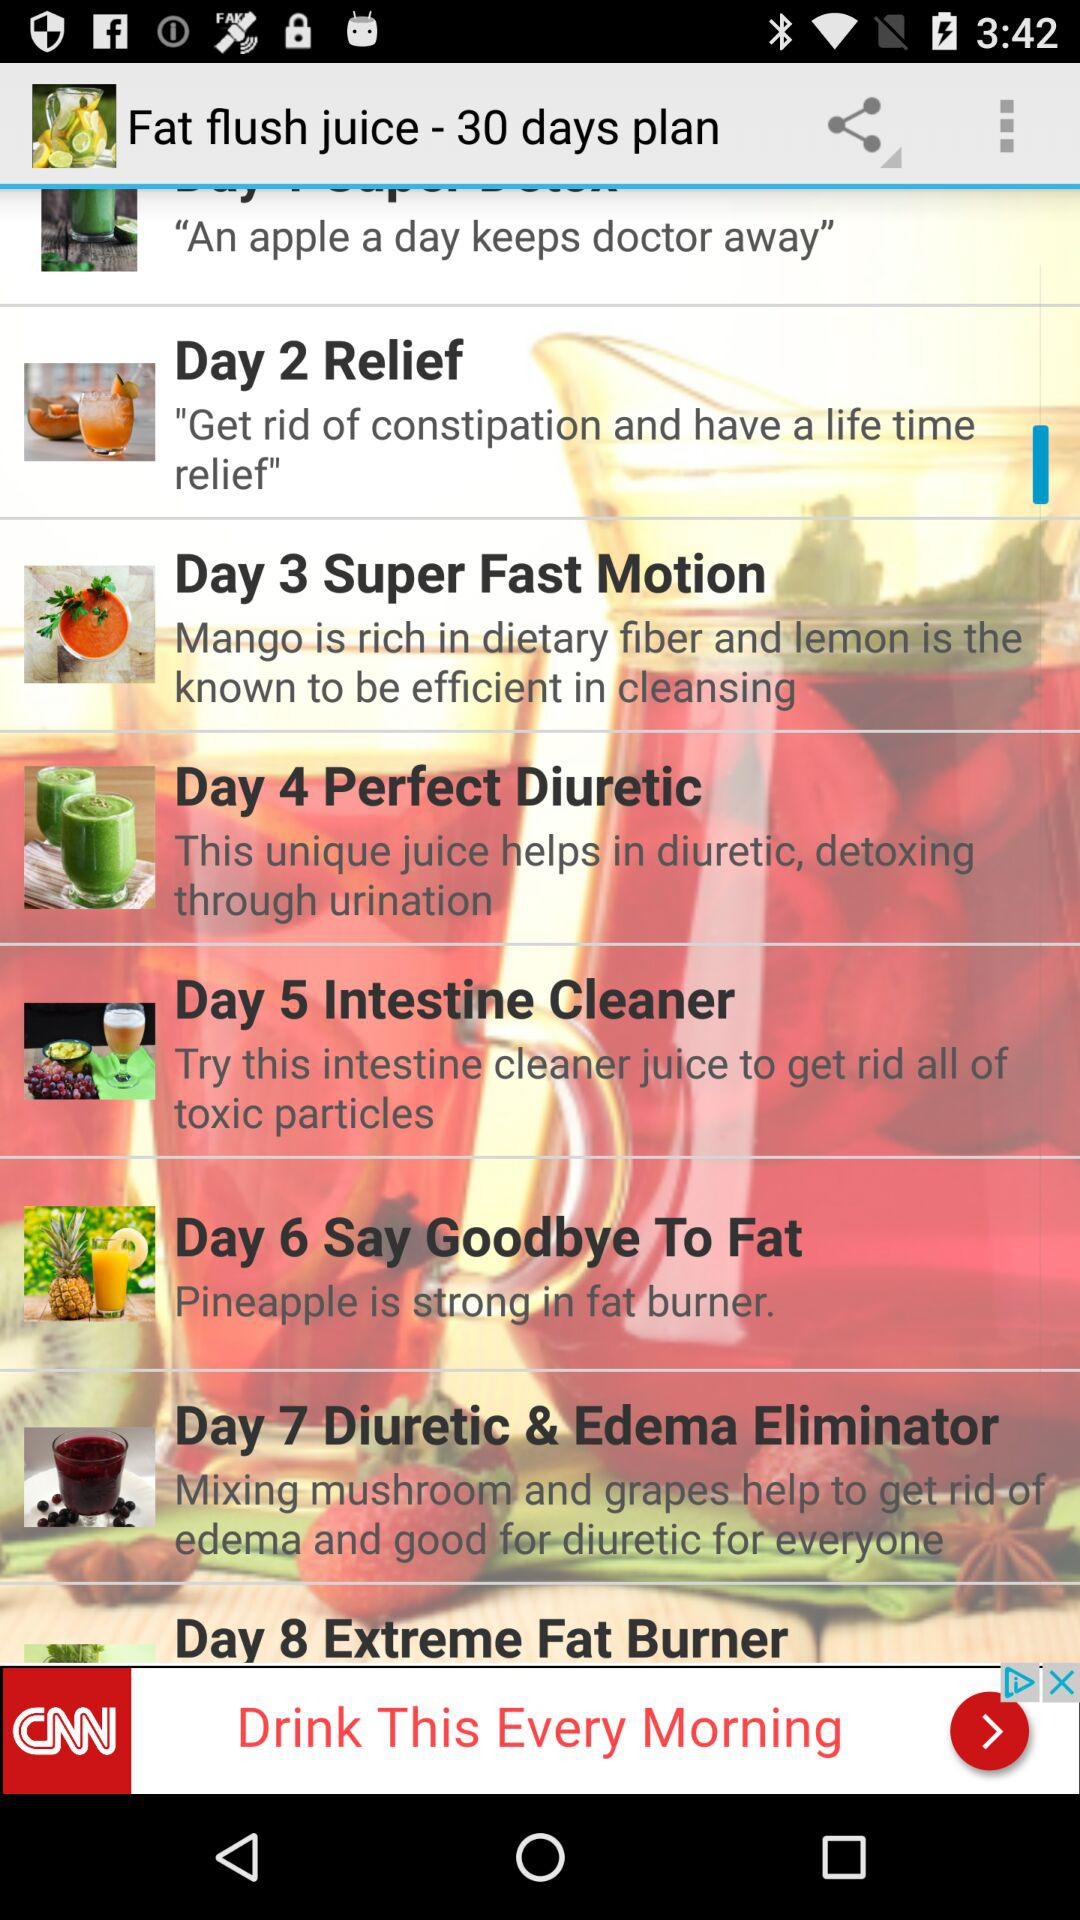Which type of juice is recommended for day 5? The type of juice that is recommended for day 5 is "Intestine Cleaner". 